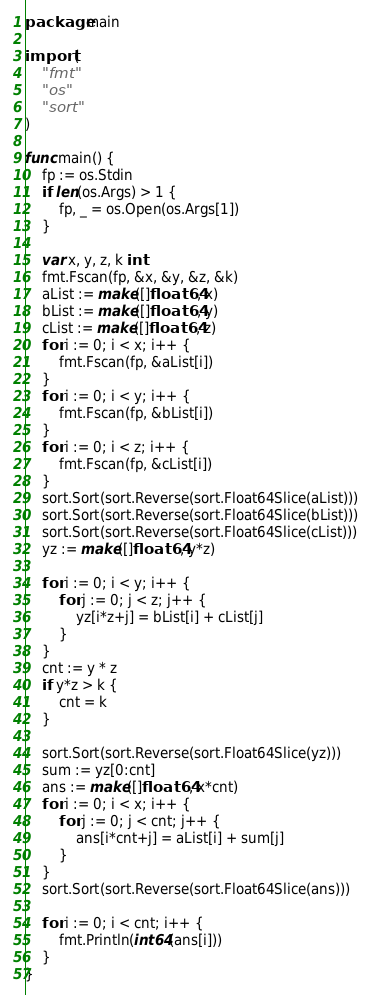<code> <loc_0><loc_0><loc_500><loc_500><_Go_>package main

import (
	"fmt"
	"os"
	"sort"
)

func main() {
	fp := os.Stdin
	if len(os.Args) > 1 {
		fp, _ = os.Open(os.Args[1])
	}

	var x, y, z, k int
	fmt.Fscan(fp, &x, &y, &z, &k)
	aList := make([]float64, x)
	bList := make([]float64, y)
	cList := make([]float64, z)
	for i := 0; i < x; i++ {
		fmt.Fscan(fp, &aList[i])
	}
	for i := 0; i < y; i++ {
		fmt.Fscan(fp, &bList[i])
	}
	for i := 0; i < z; i++ {
		fmt.Fscan(fp, &cList[i])
	}
	sort.Sort(sort.Reverse(sort.Float64Slice(aList)))
	sort.Sort(sort.Reverse(sort.Float64Slice(bList)))
	sort.Sort(sort.Reverse(sort.Float64Slice(cList)))
	yz := make([]float64, y*z)

	for i := 0; i < y; i++ {
		for j := 0; j < z; j++ {
			yz[i*z+j] = bList[i] + cList[j]
		}
	}
	cnt := y * z
	if y*z > k {
		cnt = k
	}

	sort.Sort(sort.Reverse(sort.Float64Slice(yz)))
	sum := yz[0:cnt]
	ans := make([]float64, x*cnt)
	for i := 0; i < x; i++ {
		for j := 0; j < cnt; j++ {
			ans[i*cnt+j] = aList[i] + sum[j]
		}
	}
	sort.Sort(sort.Reverse(sort.Float64Slice(ans)))

	for i := 0; i < cnt; i++ {
		fmt.Println(int64(ans[i]))
	}
}
</code> 